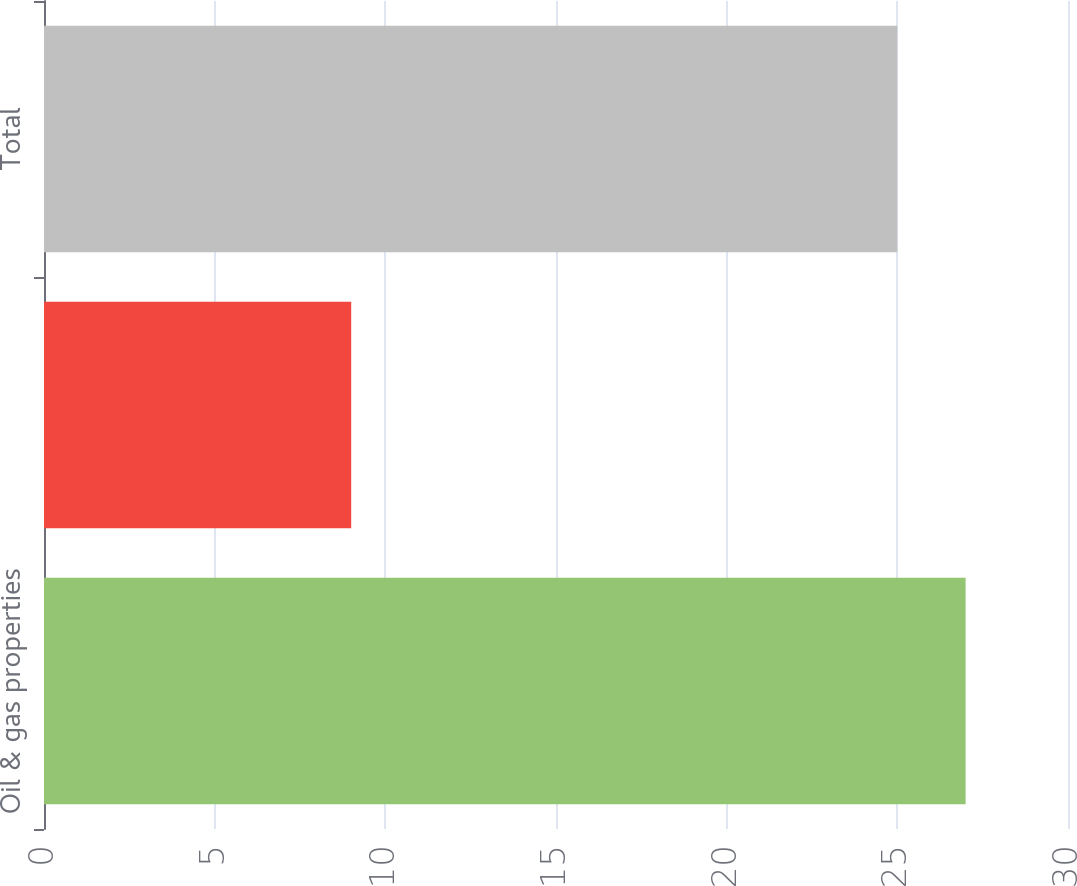Convert chart to OTSL. <chart><loc_0><loc_0><loc_500><loc_500><bar_chart><fcel>Oil & gas properties<fcel>Other properties<fcel>Total<nl><fcel>27<fcel>9<fcel>25<nl></chart> 